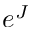<formula> <loc_0><loc_0><loc_500><loc_500>e ^ { J }</formula> 